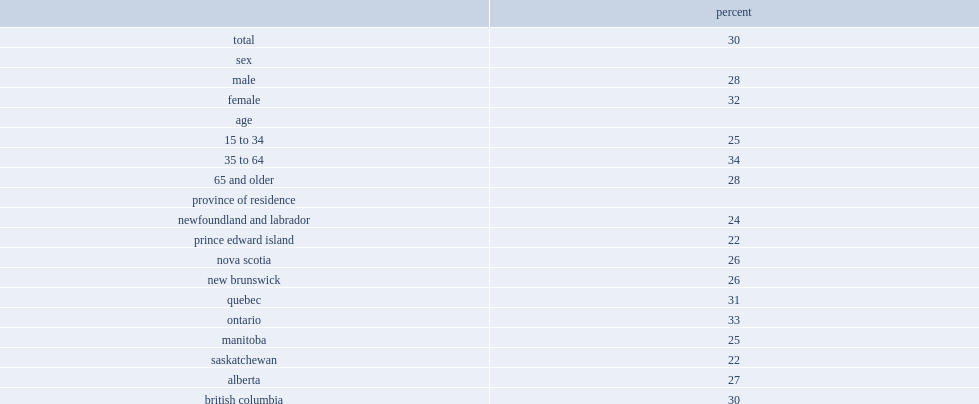Could you parse the entire table? {'header': ['', 'percent'], 'rows': [['total', '30'], ['sex', ''], ['male', '28'], ['female', '32'], ['age', ''], ['15 to 34', '25'], ['35 to 64', '34'], ['65 and older', '28'], ['province of residence', ''], ['newfoundland and labrador', '24'], ['prince edward island', '22'], ['nova scotia', '26'], ['new brunswick', '26'], ['quebec', '31'], ['ontario', '33'], ['manitoba', '25'], ['saskatchewan', '22'], ['alberta', '27'], ['british columbia', '30'], ['country of birth', ''], ['outside canada', '38'], ['canada', '28'], ['household size', ''], ['one', '26'], ['two', '29'], ['three', '34'], ['four', '27'], ['five or more', '35'], ['weeks employed in the past 12 months', ''], ['none', '30'], ['1 to 17', '24'], ['18 to 34', '22'], ['35 to 51', '30'], ['52', '33'], ['total household income in 2017', ''], ['less than $20,000', '29'], ['$20,000 to $39,999', '32'], ['$40,000 to $59,999', '33'], ['$60,000 to $79,999', '32'], ['$80,000 to $99,999', '32'], ['$100,000 to $119,999', '26'], ['$120,000 or more', '30']]} What was the proportion of caregivers between the ages of 35 and 64 reported having unmet caregiving support needs? 34.0. What was the proportion of caregivers between the ages of 34 and younger reported having unmet caregiving support needs? 25.0. What was the proportion of caregivers between the ages of 65 and older reported having unmet caregiving support needs? 28.0. 